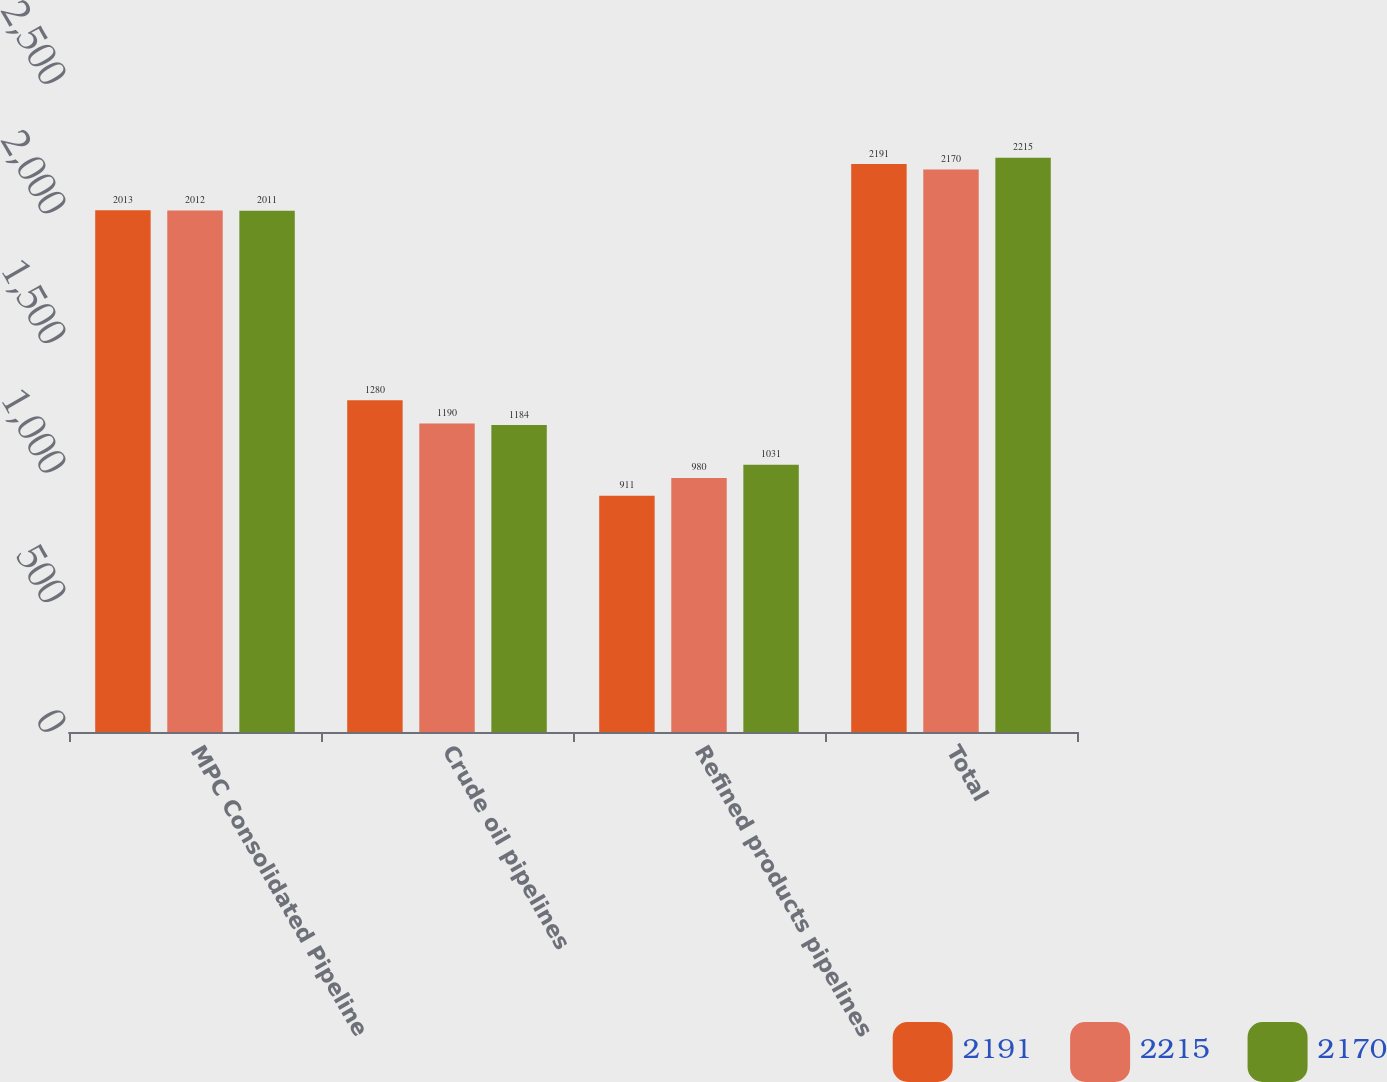<chart> <loc_0><loc_0><loc_500><loc_500><stacked_bar_chart><ecel><fcel>MPC Consolidated Pipeline<fcel>Crude oil pipelines<fcel>Refined products pipelines<fcel>Total<nl><fcel>2191<fcel>2013<fcel>1280<fcel>911<fcel>2191<nl><fcel>2215<fcel>2012<fcel>1190<fcel>980<fcel>2170<nl><fcel>2170<fcel>2011<fcel>1184<fcel>1031<fcel>2215<nl></chart> 